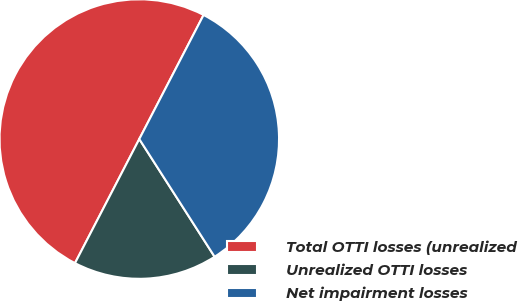<chart> <loc_0><loc_0><loc_500><loc_500><pie_chart><fcel>Total OTTI losses (unrealized<fcel>Unrealized OTTI losses<fcel>Net impairment losses<nl><fcel>50.0%<fcel>16.67%<fcel>33.33%<nl></chart> 